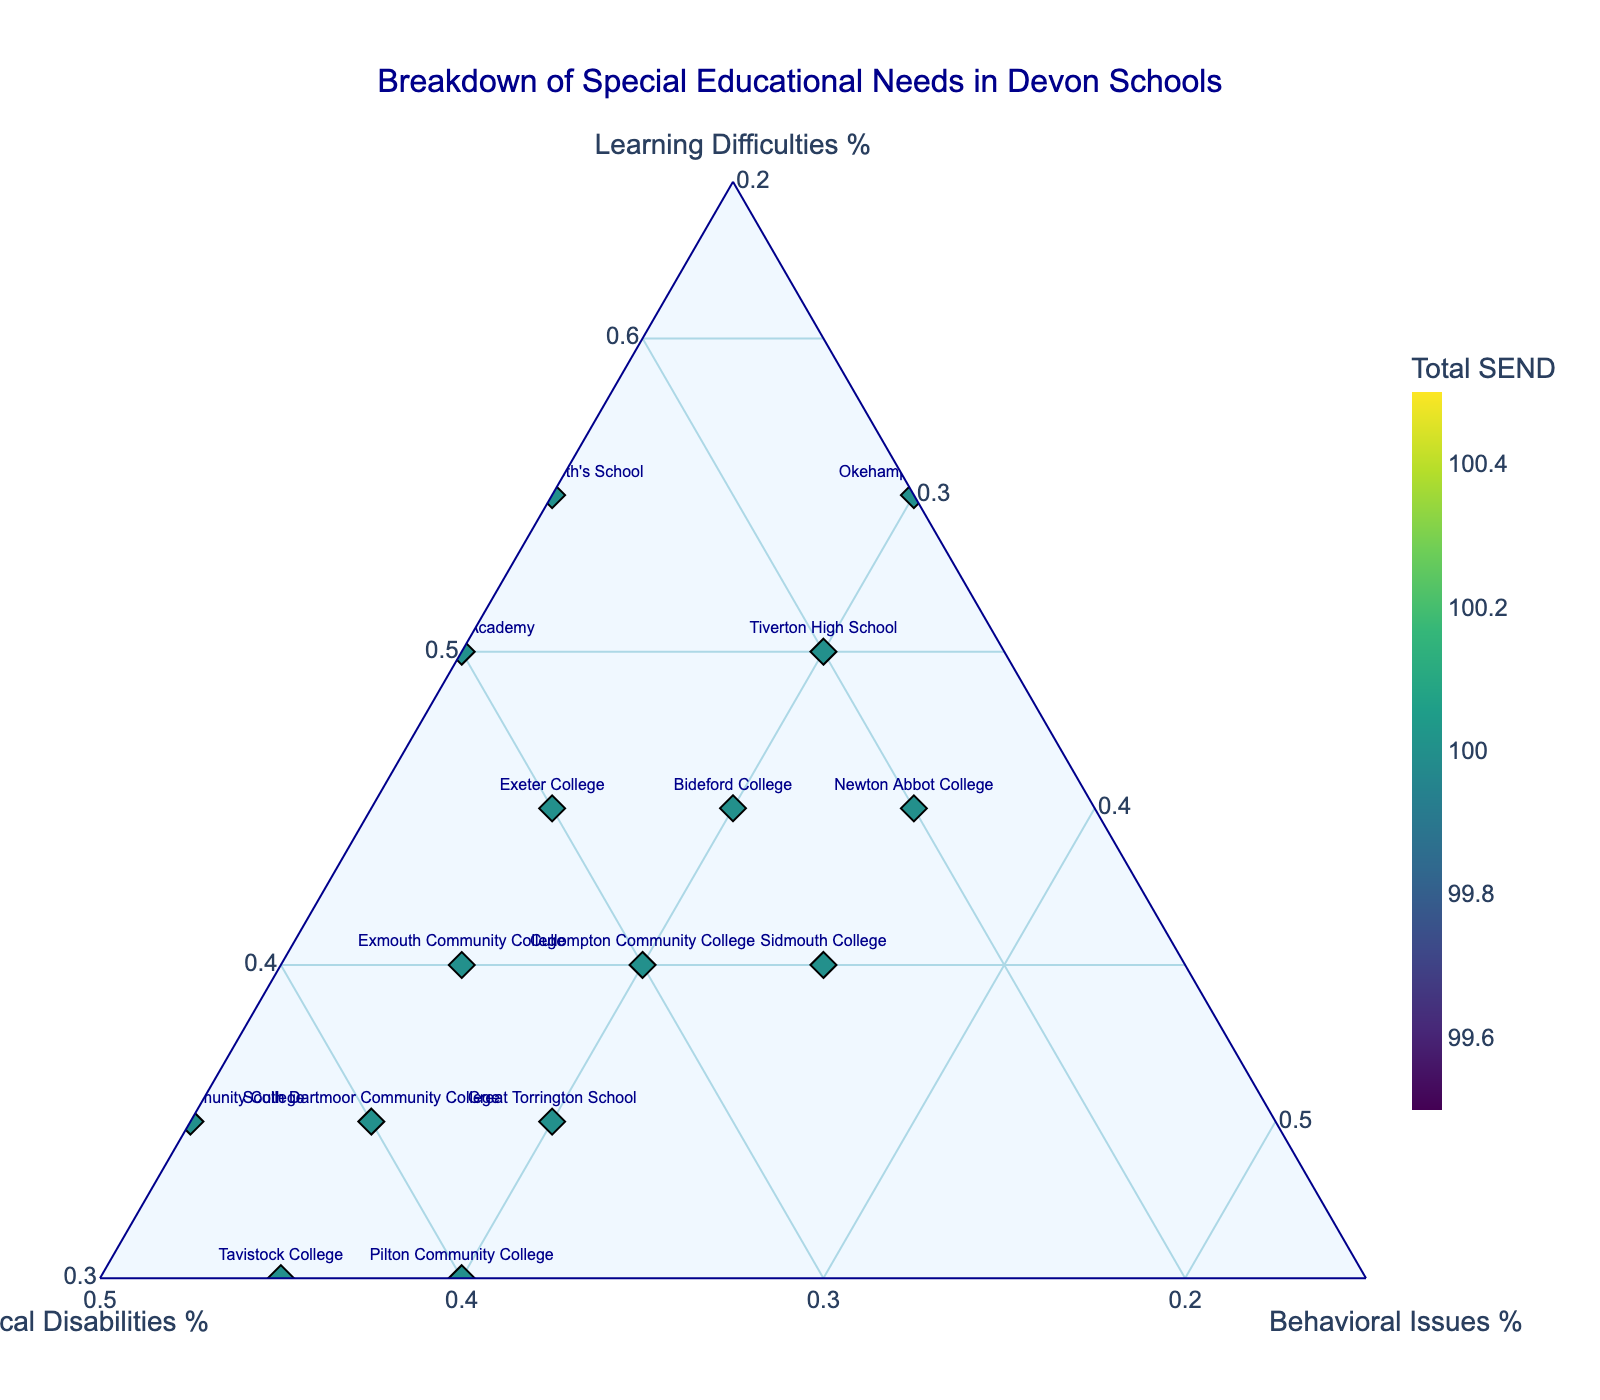What's the title of the figure? The title is displayed prominently at the top of the figure.
Answer: Breakdown of Special Educational Needs in Devon Schools How many schools are represented in the figure? There are markers representing each school on the ternary plot.
Answer: 15 Which school has the highest percentage of physical disabilities? Look for the school with the highest value on the Physical Disabilities axis (b axis).
Answer: Tavistock College Is there any school with equal percentages for all three categories? Check if any marker is positioned within the ternary plot such that the values for a, b, and c are equal.
Answer: No Which schools have the highest total SEND? The color of the markers indicates the total number of SEND, with a colorbar showing reference values. Identify the markers with the darkest hues.
Answer: Okehampton College, Queen Elizabeth's School What is the average percentage of learning difficulties across all schools? Sum the percentages of learning difficulties for all schools, then divide by the number of schools. Calculation: (45+40+50+35+55+40+30+45+35+50+40+35+45+30+55) ÷ 15 = 41.33%
Answer: 41.33% Which schools have a higher percentage of behavioral issues than physical disabilities? Compare the locations of markers relative to the b-axis (Physical Disabilities) and c-axis (Behavioral Issues). Identify the schools where behavioral issues values exceed physical disabilities.
Answer: Sidmouth College, Newton Abbot College Which school has the closest distribution to an equal split among the three categories? Look for the school where the marker is closest to the center of the ternary plot, indicating balanced percentages of each category.
Answer: Cullompton Community College How does Exmouth Community College's percentage of physical disabilities compare with Okehampton College's? Find the percentage values on the b-axis for both schools and compare them.
Answer: Exmouth Community College has higher percentages of physical disabilities than Okehampton College 